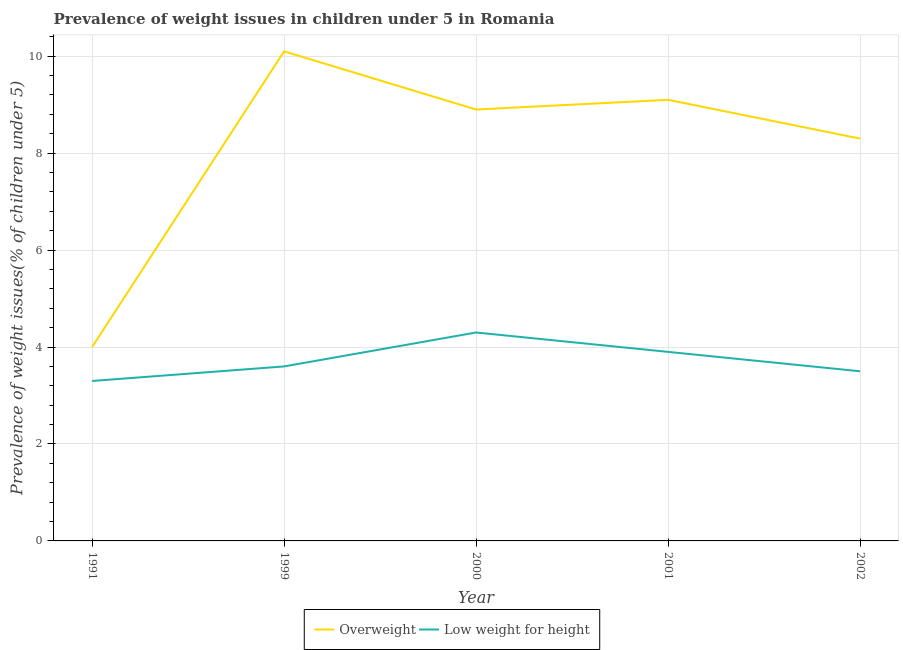How many different coloured lines are there?
Your answer should be very brief. 2. Is the number of lines equal to the number of legend labels?
Your response must be concise. Yes. What is the percentage of overweight children in 1999?
Ensure brevity in your answer.  10.1. Across all years, what is the maximum percentage of overweight children?
Your answer should be compact. 10.1. In which year was the percentage of underweight children maximum?
Give a very brief answer. 2000. What is the total percentage of overweight children in the graph?
Ensure brevity in your answer.  40.4. What is the difference between the percentage of overweight children in 1999 and that in 2001?
Make the answer very short. 1. What is the difference between the percentage of underweight children in 1999 and the percentage of overweight children in 2001?
Provide a short and direct response. -5.5. What is the average percentage of underweight children per year?
Your answer should be compact. 3.72. In the year 1991, what is the difference between the percentage of overweight children and percentage of underweight children?
Your answer should be compact. 0.7. In how many years, is the percentage of overweight children greater than 9.6 %?
Your answer should be very brief. 1. What is the ratio of the percentage of overweight children in 2000 to that in 2002?
Your answer should be compact. 1.07. Is the percentage of overweight children in 1999 less than that in 2000?
Ensure brevity in your answer.  No. What is the difference between the highest and the second highest percentage of overweight children?
Offer a very short reply. 1. What is the difference between the highest and the lowest percentage of overweight children?
Ensure brevity in your answer.  6.1. Is the sum of the percentage of underweight children in 1999 and 2001 greater than the maximum percentage of overweight children across all years?
Your answer should be very brief. No. How many years are there in the graph?
Ensure brevity in your answer.  5. Does the graph contain any zero values?
Keep it short and to the point. No. How many legend labels are there?
Keep it short and to the point. 2. What is the title of the graph?
Make the answer very short. Prevalence of weight issues in children under 5 in Romania. What is the label or title of the X-axis?
Give a very brief answer. Year. What is the label or title of the Y-axis?
Make the answer very short. Prevalence of weight issues(% of children under 5). What is the Prevalence of weight issues(% of children under 5) of Low weight for height in 1991?
Your answer should be compact. 3.3. What is the Prevalence of weight issues(% of children under 5) of Overweight in 1999?
Provide a succinct answer. 10.1. What is the Prevalence of weight issues(% of children under 5) in Low weight for height in 1999?
Your answer should be very brief. 3.6. What is the Prevalence of weight issues(% of children under 5) in Overweight in 2000?
Provide a short and direct response. 8.9. What is the Prevalence of weight issues(% of children under 5) in Low weight for height in 2000?
Your response must be concise. 4.3. What is the Prevalence of weight issues(% of children under 5) of Overweight in 2001?
Give a very brief answer. 9.1. What is the Prevalence of weight issues(% of children under 5) in Low weight for height in 2001?
Offer a terse response. 3.9. What is the Prevalence of weight issues(% of children under 5) of Overweight in 2002?
Offer a very short reply. 8.3. What is the Prevalence of weight issues(% of children under 5) of Low weight for height in 2002?
Give a very brief answer. 3.5. Across all years, what is the maximum Prevalence of weight issues(% of children under 5) in Overweight?
Provide a succinct answer. 10.1. Across all years, what is the maximum Prevalence of weight issues(% of children under 5) in Low weight for height?
Your response must be concise. 4.3. Across all years, what is the minimum Prevalence of weight issues(% of children under 5) of Overweight?
Make the answer very short. 4. Across all years, what is the minimum Prevalence of weight issues(% of children under 5) in Low weight for height?
Provide a succinct answer. 3.3. What is the total Prevalence of weight issues(% of children under 5) in Overweight in the graph?
Your answer should be compact. 40.4. What is the total Prevalence of weight issues(% of children under 5) in Low weight for height in the graph?
Your answer should be compact. 18.6. What is the difference between the Prevalence of weight issues(% of children under 5) of Overweight in 1991 and that in 1999?
Your response must be concise. -6.1. What is the difference between the Prevalence of weight issues(% of children under 5) in Low weight for height in 1991 and that in 1999?
Your answer should be compact. -0.3. What is the difference between the Prevalence of weight issues(% of children under 5) in Low weight for height in 1991 and that in 2000?
Your answer should be very brief. -1. What is the difference between the Prevalence of weight issues(% of children under 5) of Overweight in 1991 and that in 2001?
Offer a terse response. -5.1. What is the difference between the Prevalence of weight issues(% of children under 5) in Overweight in 1991 and that in 2002?
Your answer should be very brief. -4.3. What is the difference between the Prevalence of weight issues(% of children under 5) in Overweight in 1999 and that in 2000?
Provide a succinct answer. 1.2. What is the difference between the Prevalence of weight issues(% of children under 5) in Low weight for height in 1999 and that in 2000?
Offer a very short reply. -0.7. What is the difference between the Prevalence of weight issues(% of children under 5) of Overweight in 1999 and that in 2001?
Provide a short and direct response. 1. What is the difference between the Prevalence of weight issues(% of children under 5) of Low weight for height in 1999 and that in 2001?
Your answer should be very brief. -0.3. What is the difference between the Prevalence of weight issues(% of children under 5) of Low weight for height in 1999 and that in 2002?
Ensure brevity in your answer.  0.1. What is the difference between the Prevalence of weight issues(% of children under 5) in Overweight in 2000 and that in 2001?
Keep it short and to the point. -0.2. What is the difference between the Prevalence of weight issues(% of children under 5) of Low weight for height in 2000 and that in 2001?
Offer a very short reply. 0.4. What is the difference between the Prevalence of weight issues(% of children under 5) of Low weight for height in 2000 and that in 2002?
Give a very brief answer. 0.8. What is the difference between the Prevalence of weight issues(% of children under 5) of Overweight in 2001 and that in 2002?
Keep it short and to the point. 0.8. What is the difference between the Prevalence of weight issues(% of children under 5) in Low weight for height in 2001 and that in 2002?
Make the answer very short. 0.4. What is the difference between the Prevalence of weight issues(% of children under 5) of Overweight in 1991 and the Prevalence of weight issues(% of children under 5) of Low weight for height in 1999?
Keep it short and to the point. 0.4. What is the difference between the Prevalence of weight issues(% of children under 5) in Overweight in 1991 and the Prevalence of weight issues(% of children under 5) in Low weight for height in 2001?
Your answer should be compact. 0.1. What is the difference between the Prevalence of weight issues(% of children under 5) of Overweight in 1991 and the Prevalence of weight issues(% of children under 5) of Low weight for height in 2002?
Provide a succinct answer. 0.5. What is the difference between the Prevalence of weight issues(% of children under 5) of Overweight in 1999 and the Prevalence of weight issues(% of children under 5) of Low weight for height in 2000?
Ensure brevity in your answer.  5.8. What is the difference between the Prevalence of weight issues(% of children under 5) of Overweight in 1999 and the Prevalence of weight issues(% of children under 5) of Low weight for height in 2001?
Give a very brief answer. 6.2. What is the difference between the Prevalence of weight issues(% of children under 5) of Overweight in 1999 and the Prevalence of weight issues(% of children under 5) of Low weight for height in 2002?
Give a very brief answer. 6.6. What is the difference between the Prevalence of weight issues(% of children under 5) in Overweight in 2000 and the Prevalence of weight issues(% of children under 5) in Low weight for height in 2002?
Give a very brief answer. 5.4. What is the difference between the Prevalence of weight issues(% of children under 5) in Overweight in 2001 and the Prevalence of weight issues(% of children under 5) in Low weight for height in 2002?
Provide a short and direct response. 5.6. What is the average Prevalence of weight issues(% of children under 5) in Overweight per year?
Provide a short and direct response. 8.08. What is the average Prevalence of weight issues(% of children under 5) in Low weight for height per year?
Keep it short and to the point. 3.72. In the year 1999, what is the difference between the Prevalence of weight issues(% of children under 5) of Overweight and Prevalence of weight issues(% of children under 5) of Low weight for height?
Ensure brevity in your answer.  6.5. In the year 2000, what is the difference between the Prevalence of weight issues(% of children under 5) of Overweight and Prevalence of weight issues(% of children under 5) of Low weight for height?
Offer a terse response. 4.6. In the year 2001, what is the difference between the Prevalence of weight issues(% of children under 5) in Overweight and Prevalence of weight issues(% of children under 5) in Low weight for height?
Offer a terse response. 5.2. In the year 2002, what is the difference between the Prevalence of weight issues(% of children under 5) in Overweight and Prevalence of weight issues(% of children under 5) in Low weight for height?
Provide a succinct answer. 4.8. What is the ratio of the Prevalence of weight issues(% of children under 5) of Overweight in 1991 to that in 1999?
Ensure brevity in your answer.  0.4. What is the ratio of the Prevalence of weight issues(% of children under 5) of Low weight for height in 1991 to that in 1999?
Offer a very short reply. 0.92. What is the ratio of the Prevalence of weight issues(% of children under 5) of Overweight in 1991 to that in 2000?
Your answer should be compact. 0.45. What is the ratio of the Prevalence of weight issues(% of children under 5) in Low weight for height in 1991 to that in 2000?
Give a very brief answer. 0.77. What is the ratio of the Prevalence of weight issues(% of children under 5) of Overweight in 1991 to that in 2001?
Make the answer very short. 0.44. What is the ratio of the Prevalence of weight issues(% of children under 5) in Low weight for height in 1991 to that in 2001?
Your response must be concise. 0.85. What is the ratio of the Prevalence of weight issues(% of children under 5) in Overweight in 1991 to that in 2002?
Offer a terse response. 0.48. What is the ratio of the Prevalence of weight issues(% of children under 5) of Low weight for height in 1991 to that in 2002?
Your answer should be very brief. 0.94. What is the ratio of the Prevalence of weight issues(% of children under 5) in Overweight in 1999 to that in 2000?
Offer a very short reply. 1.13. What is the ratio of the Prevalence of weight issues(% of children under 5) in Low weight for height in 1999 to that in 2000?
Give a very brief answer. 0.84. What is the ratio of the Prevalence of weight issues(% of children under 5) in Overweight in 1999 to that in 2001?
Ensure brevity in your answer.  1.11. What is the ratio of the Prevalence of weight issues(% of children under 5) in Overweight in 1999 to that in 2002?
Give a very brief answer. 1.22. What is the ratio of the Prevalence of weight issues(% of children under 5) of Low weight for height in 1999 to that in 2002?
Provide a succinct answer. 1.03. What is the ratio of the Prevalence of weight issues(% of children under 5) of Low weight for height in 2000 to that in 2001?
Give a very brief answer. 1.1. What is the ratio of the Prevalence of weight issues(% of children under 5) in Overweight in 2000 to that in 2002?
Ensure brevity in your answer.  1.07. What is the ratio of the Prevalence of weight issues(% of children under 5) in Low weight for height in 2000 to that in 2002?
Offer a terse response. 1.23. What is the ratio of the Prevalence of weight issues(% of children under 5) in Overweight in 2001 to that in 2002?
Offer a terse response. 1.1. What is the ratio of the Prevalence of weight issues(% of children under 5) in Low weight for height in 2001 to that in 2002?
Keep it short and to the point. 1.11. What is the difference between the highest and the second highest Prevalence of weight issues(% of children under 5) in Low weight for height?
Your answer should be very brief. 0.4. What is the difference between the highest and the lowest Prevalence of weight issues(% of children under 5) of Overweight?
Make the answer very short. 6.1. 